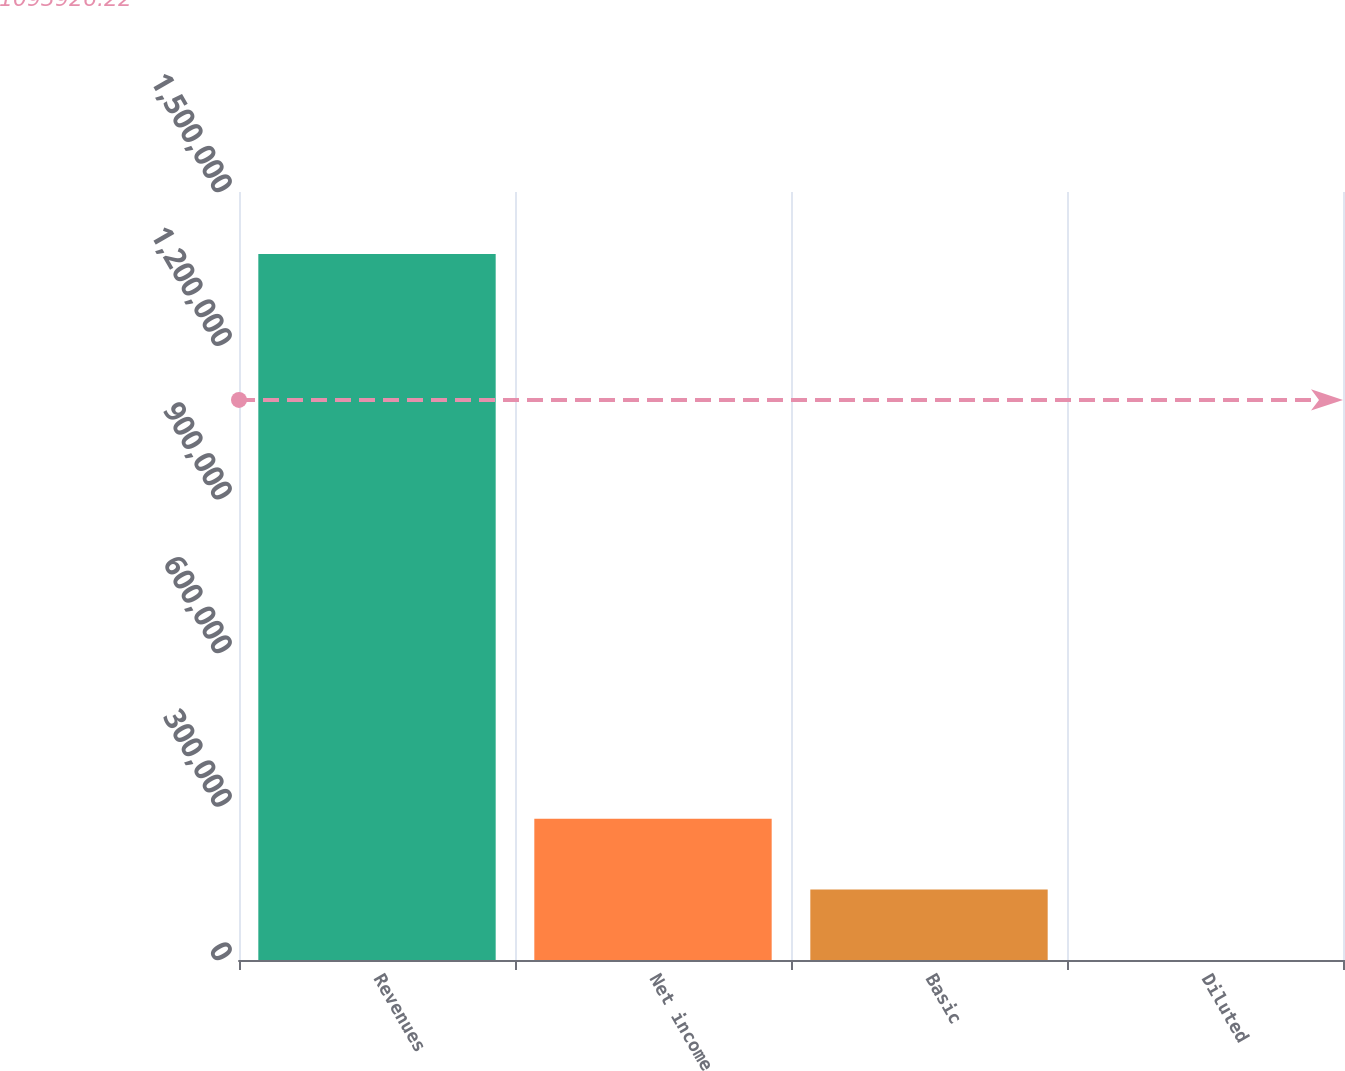Convert chart. <chart><loc_0><loc_0><loc_500><loc_500><bar_chart><fcel>Revenues<fcel>Net income<fcel>Basic<fcel>Diluted<nl><fcel>1.3787e+06<fcel>275742<fcel>137871<fcel>0.94<nl></chart> 